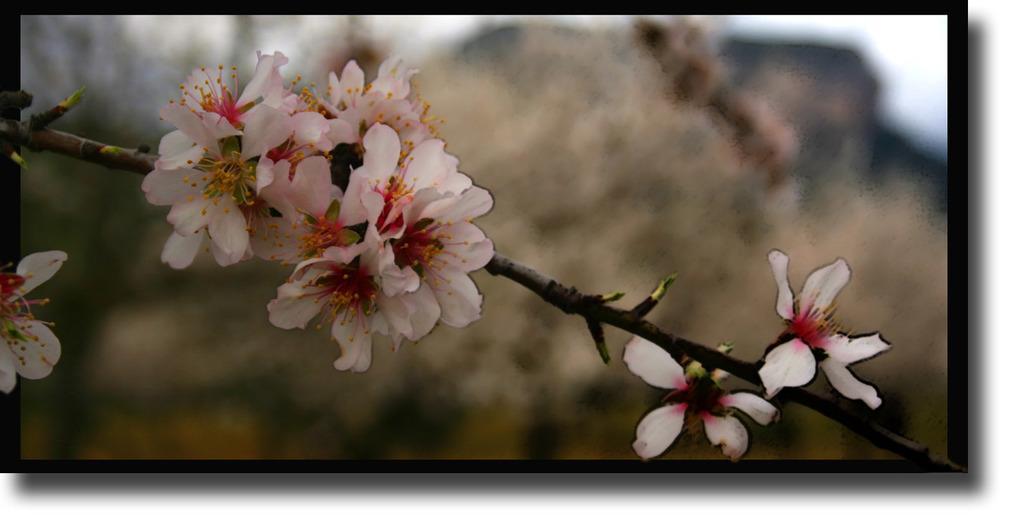How would you summarize this image in a sentence or two? These are the white color flowers. 